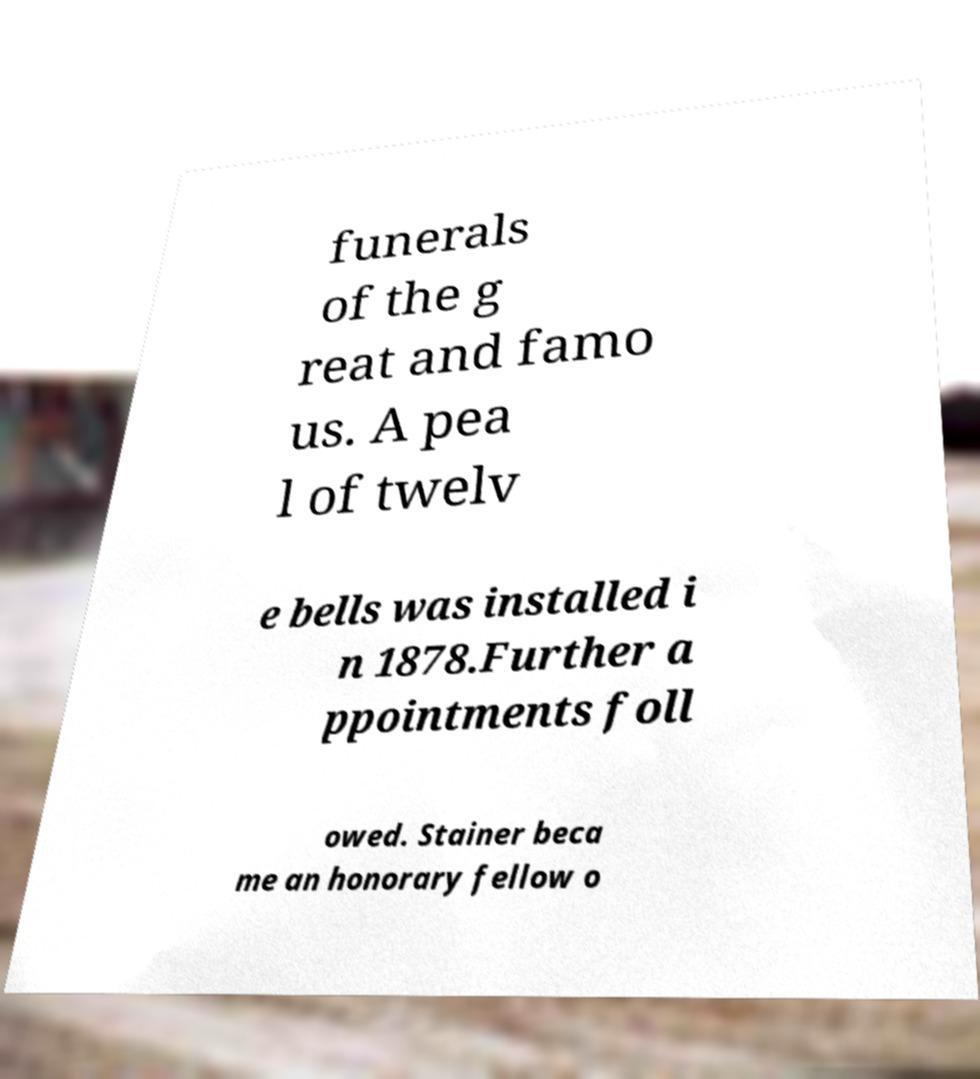Can you accurately transcribe the text from the provided image for me? funerals of the g reat and famo us. A pea l of twelv e bells was installed i n 1878.Further a ppointments foll owed. Stainer beca me an honorary fellow o 